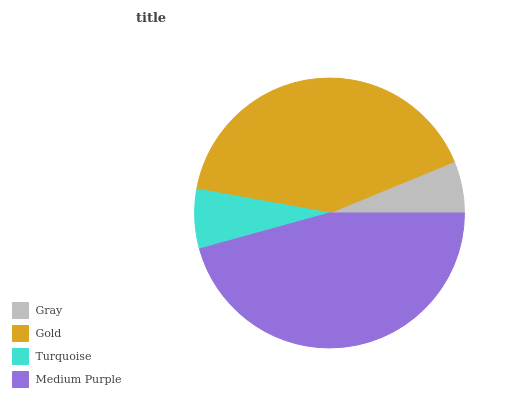Is Gray the minimum?
Answer yes or no. Yes. Is Medium Purple the maximum?
Answer yes or no. Yes. Is Gold the minimum?
Answer yes or no. No. Is Gold the maximum?
Answer yes or no. No. Is Gold greater than Gray?
Answer yes or no. Yes. Is Gray less than Gold?
Answer yes or no. Yes. Is Gray greater than Gold?
Answer yes or no. No. Is Gold less than Gray?
Answer yes or no. No. Is Gold the high median?
Answer yes or no. Yes. Is Turquoise the low median?
Answer yes or no. Yes. Is Turquoise the high median?
Answer yes or no. No. Is Gray the low median?
Answer yes or no. No. 